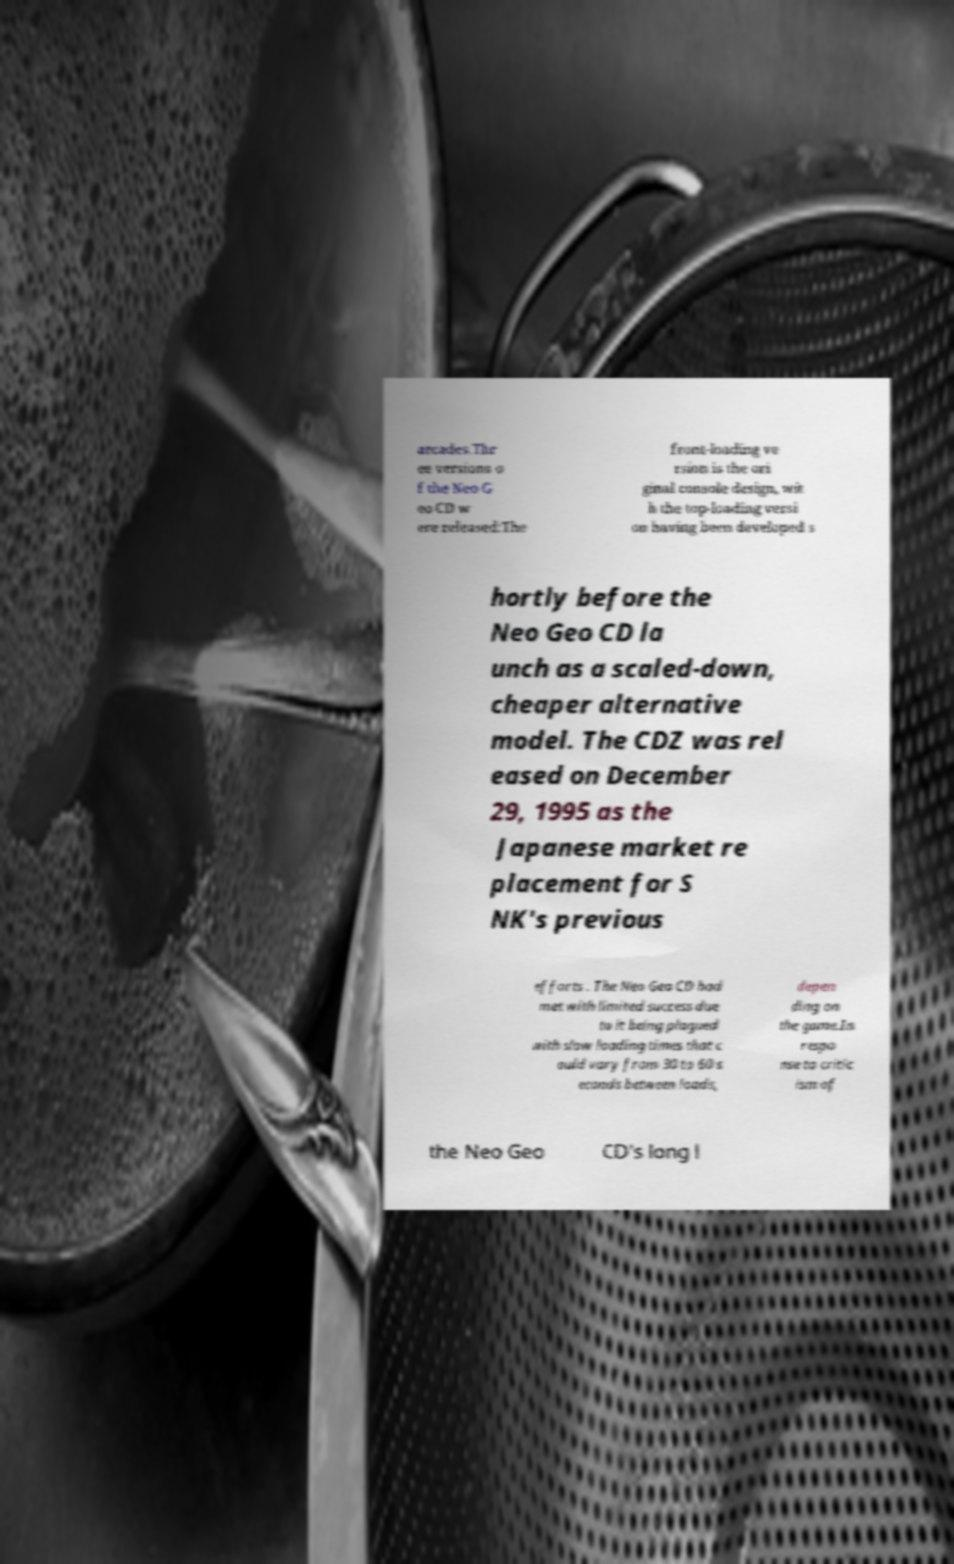Could you extract and type out the text from this image? arcades.Thr ee versions o f the Neo G eo CD w ere released:The front-loading ve rsion is the ori ginal console design, wit h the top-loading versi on having been developed s hortly before the Neo Geo CD la unch as a scaled-down, cheaper alternative model. The CDZ was rel eased on December 29, 1995 as the Japanese market re placement for S NK's previous efforts . The Neo Geo CD had met with limited success due to it being plagued with slow loading times that c ould vary from 30 to 60 s econds between loads, depen ding on the game.In respo nse to critic ism of the Neo Geo CD's long l 